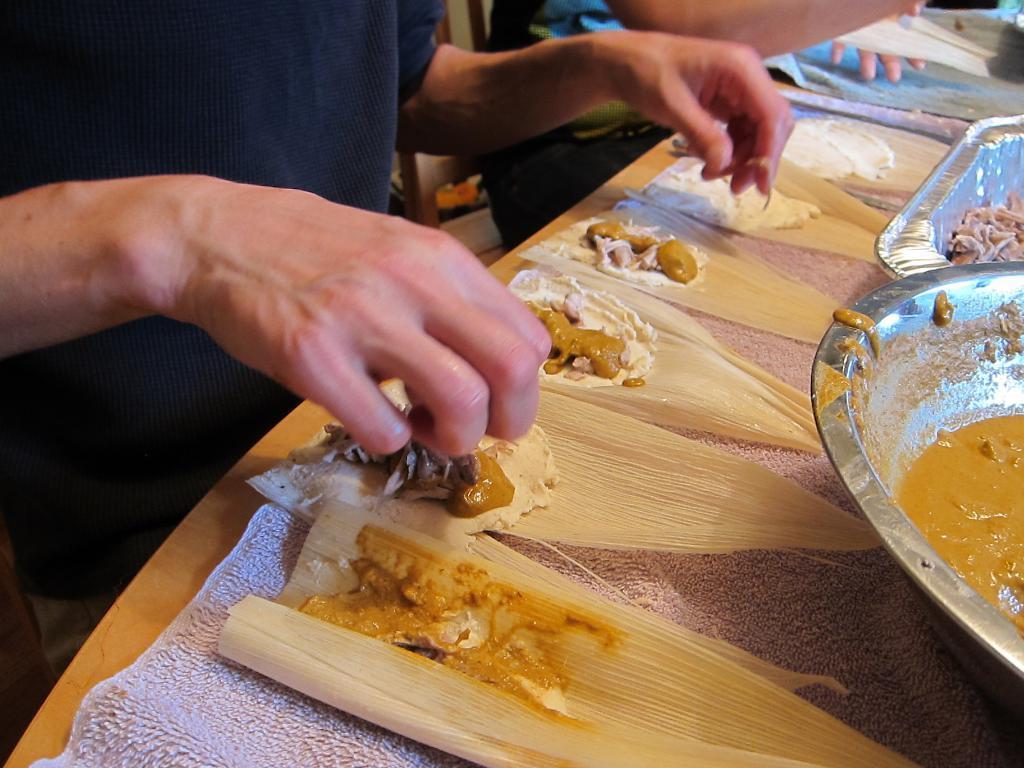Could you give a brief overview of what you see in this image? This picture shows couple of people seated on the chairs and and we see food in the leaves on the table and we see a bowl and a aluminium tray on the table. 